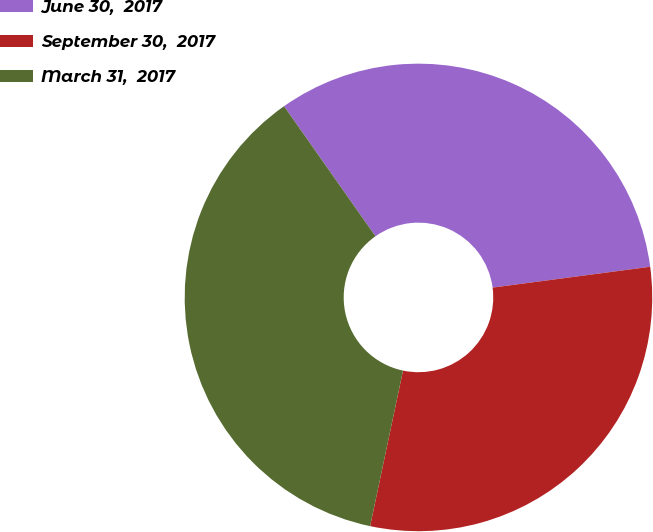<chart> <loc_0><loc_0><loc_500><loc_500><pie_chart><fcel>June 30,  2017<fcel>September 30,  2017<fcel>March 31,  2017<nl><fcel>32.66%<fcel>30.41%<fcel>36.93%<nl></chart> 